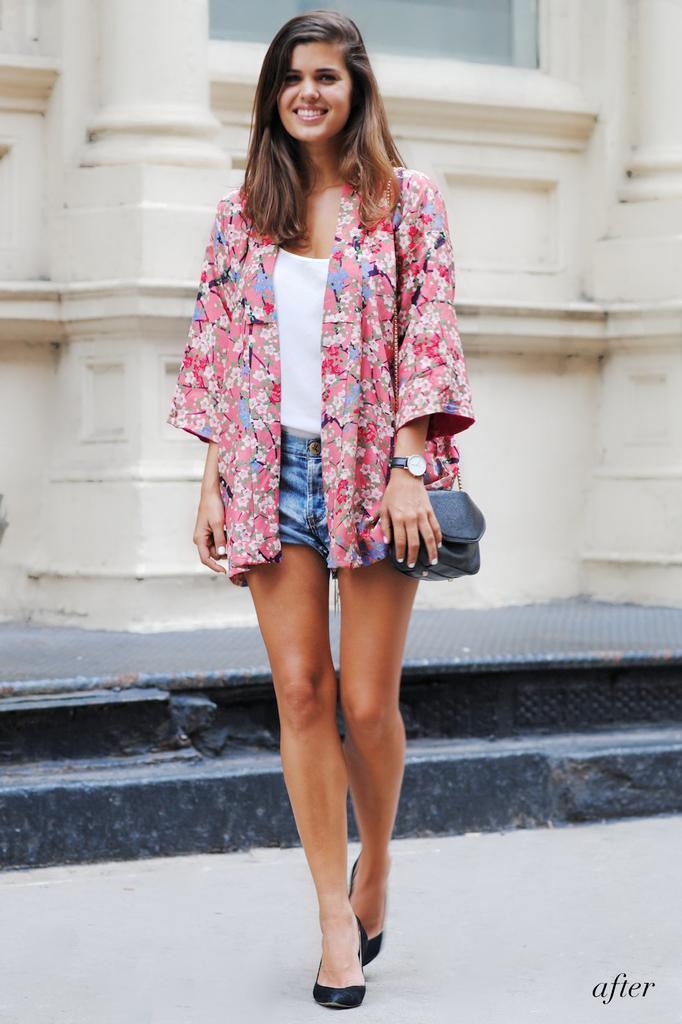Please provide a concise description of this image. In this image I can see a woman is standing and I can see she is carrying a bag. I can also see smile on her face and I can see she is wearing watch and blue shorts. In the background I can see white colour building. 